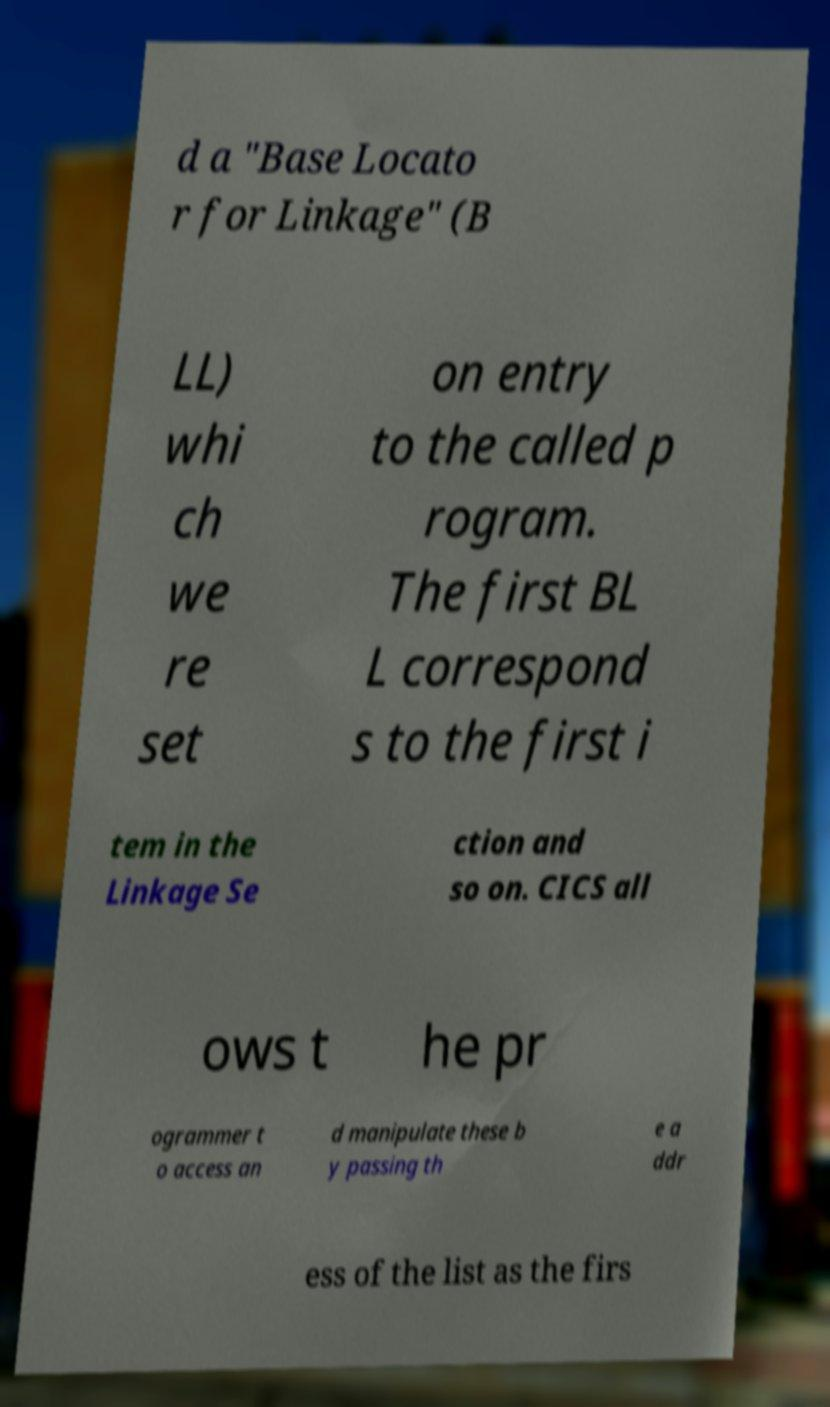Can you read and provide the text displayed in the image?This photo seems to have some interesting text. Can you extract and type it out for me? d a "Base Locato r for Linkage" (B LL) whi ch we re set on entry to the called p rogram. The first BL L correspond s to the first i tem in the Linkage Se ction and so on. CICS all ows t he pr ogrammer t o access an d manipulate these b y passing th e a ddr ess of the list as the firs 